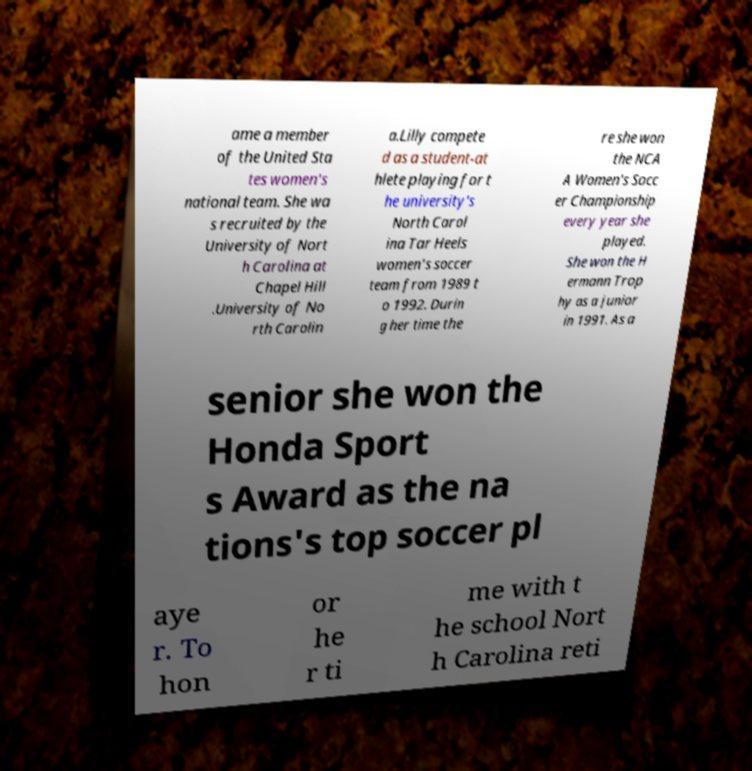Could you extract and type out the text from this image? ame a member of the United Sta tes women's national team. She wa s recruited by the University of Nort h Carolina at Chapel Hill .University of No rth Carolin a.Lilly compete d as a student-at hlete playing for t he university's North Carol ina Tar Heels women's soccer team from 1989 t o 1992. Durin g her time the re she won the NCA A Women's Socc er Championship every year she played. She won the H ermann Trop hy as a junior in 1991. As a senior she won the Honda Sport s Award as the na tions's top soccer pl aye r. To hon or he r ti me with t he school Nort h Carolina reti 